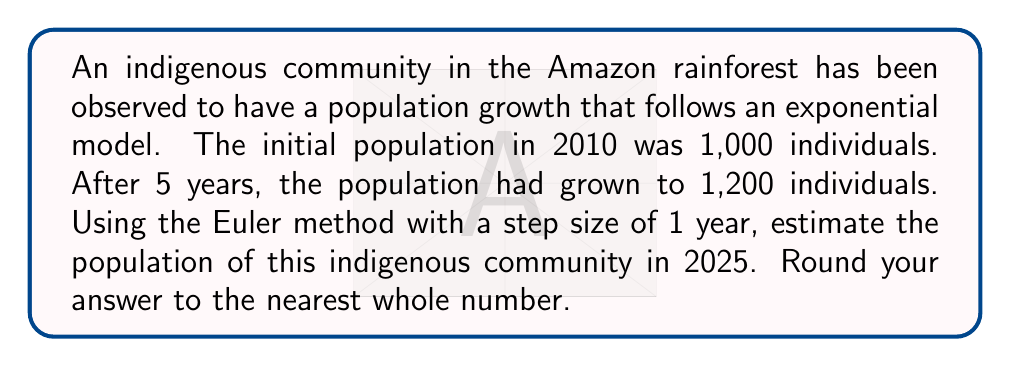Help me with this question. To solve this problem, we'll follow these steps:

1) First, we need to determine the growth rate (r) of the population using the given data.
2) Then, we'll use the Euler method to estimate the population in 2025.

Step 1: Determining the growth rate

The exponential growth model is given by:

$$ P(t) = P_0 e^{rt} $$

Where $P_0$ is the initial population, r is the growth rate, and t is time.

We know that $P_0 = 1000$, $P(5) = 1200$, so:

$$ 1200 = 1000 e^{5r} $$

Solving for r:

$$ \frac{1200}{1000} = e^{5r} $$
$$ 1.2 = e^{5r} $$
$$ \ln(1.2) = 5r $$
$$ r = \frac{\ln(1.2)}{5} \approx 0.0365 $$

Step 2: Using the Euler method

The Euler method for this problem can be expressed as:

$$ P_{n+1} = P_n + rP_n\Delta t $$

Where $\Delta t$ is the step size (1 year in this case).

We need to iterate from 2010 to 2025, which is 15 steps:

$P_0 = 1000$
$P_1 = 1000 + 0.0365 * 1000 * 1 = 1036.5$
$P_2 = 1036.5 + 0.0365 * 1036.5 * 1 = 1074.33$
...

Continuing this process for 15 iterations:

$P_{15} \approx 1710.04$

Rounding to the nearest whole number, we get 1710.
Answer: 1710 